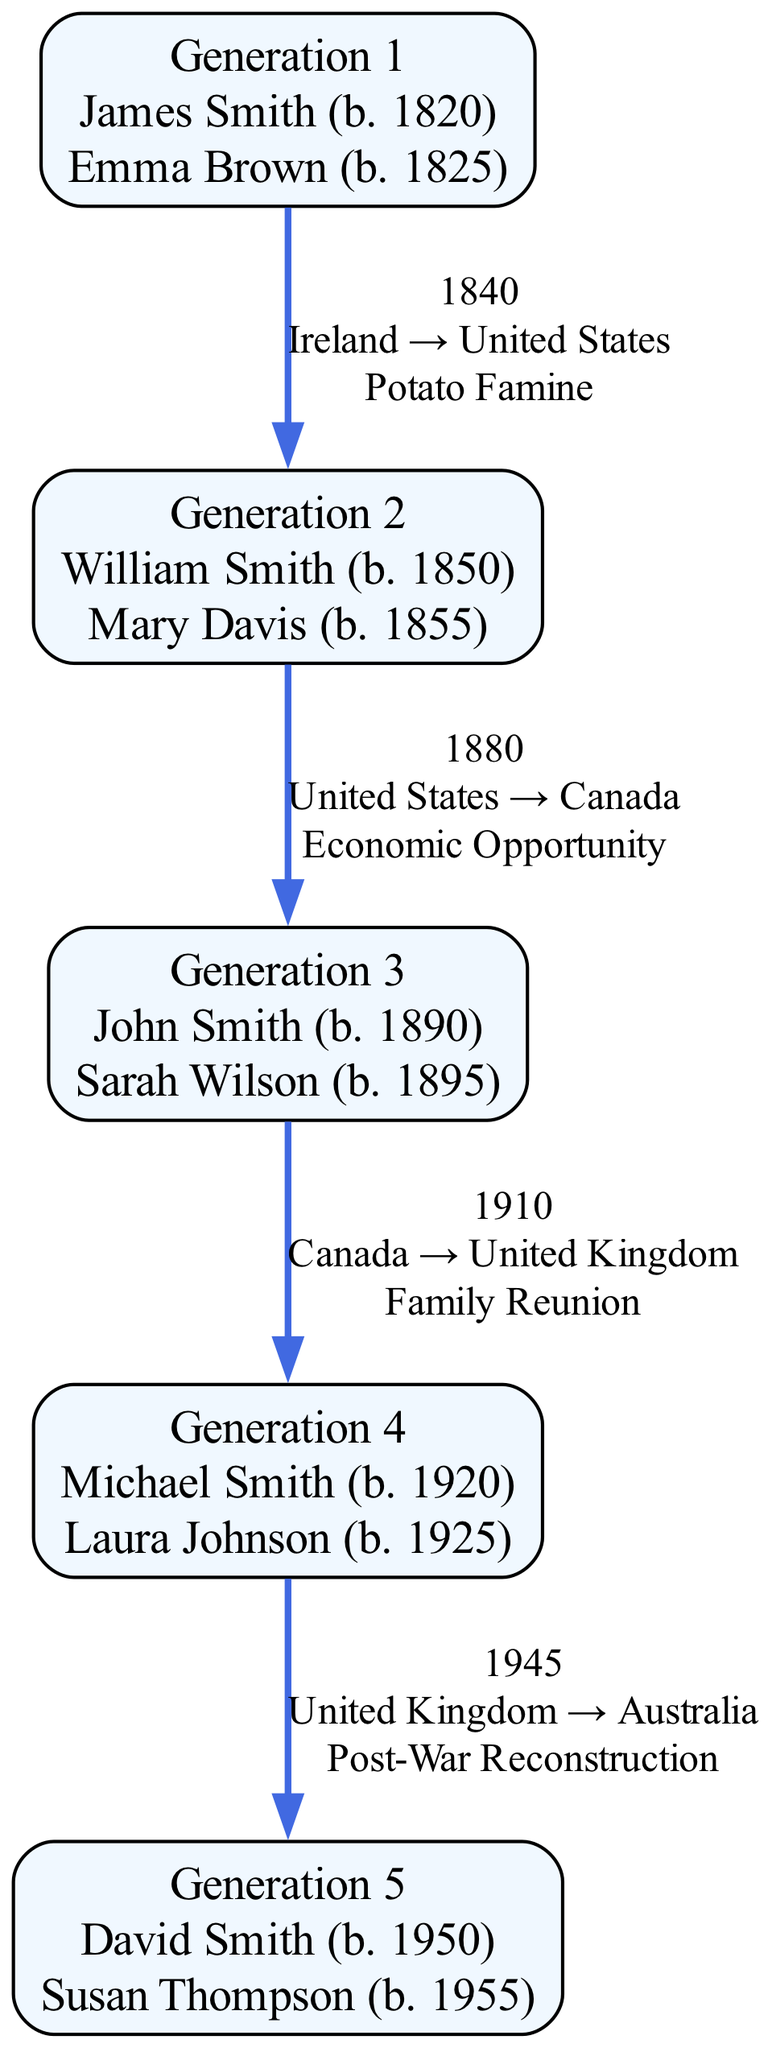What is the reason for James Smith's migration? James Smith migrated from Ireland to the United States in 1840 due to the Potato Famine, which is directly listed in the migration details for Generation 1.
Answer: Potato Famine How many generations are represented in the diagram? The diagram contains five distinct generations, each clearly labeled and separated, as observed from the numbered labels from Generation 1 to Generation 5.
Answer: 5 Which country did William Smith move to in 1880? According to the migration details for Generation 2, William Smith moved from the United States to Canada in 1880.
Answer: Canada What year did Michael Smith migrate? The migration details for Generation 4 specify that Michael Smith migrated from the United Kingdom to Australia in 1945, providing a direct answer to the question.
Answer: 1945 What is the migration path from Generation 3 to Generation 4? The migration path indicates that John Smith and Sarah Wilson moved from Canada (in Generation 3) to the United Kingdom and then Michael Smith and Laura Johnson moved to Australia (Generation 4) in 1945. Thus, it combines both generations' migration information.
Answer: Canada → United Kingdom → Australia How many moves were made from the United Kingdom? The diagram shows that there are two moves involving the United Kingdom: first from Canada to the United Kingdom in 1910 (Generation 3) and then from the United Kingdom to Australia in 1945 (Generation 4), providing a distinct count.
Answer: 2 What is the age of Susan Thompson when she migrated? Susan Thompson was born in 1955 and migrated in 1970. Therefore, the age at the time of migration can be calculated as 1970 - 1955, resulting in 15 years.
Answer: 15 Which generation migrated for career advancement? The migration for career advancement occurred in Generation 5, as indicated by the reason provided for David Smith and Susan Thompson's move from Australia to New Zealand in 1970.
Answer: Generation 5 What label represents the first generation? The first generation is labeled "Generation 1," which is clear from the top of the diagram where the generations are specifically numbered and labeled sequentially.
Answer: Generation 1 